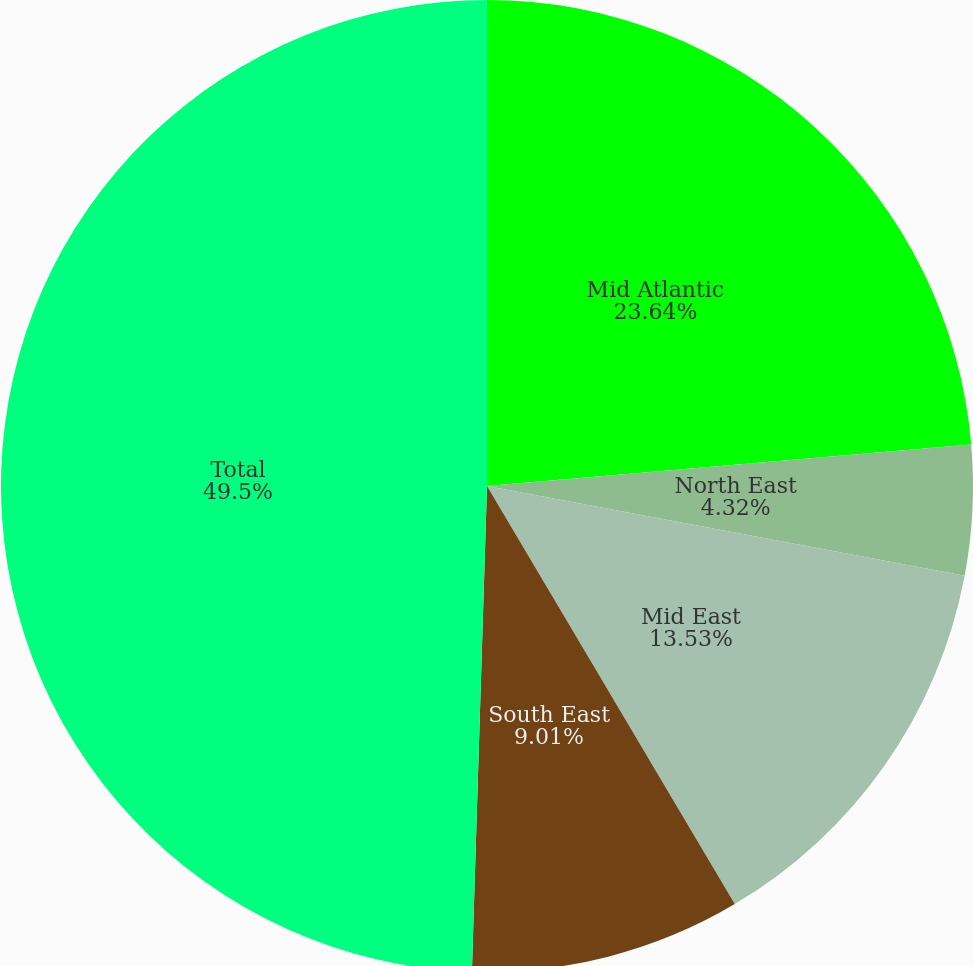Convert chart to OTSL. <chart><loc_0><loc_0><loc_500><loc_500><pie_chart><fcel>Mid Atlantic<fcel>North East<fcel>Mid East<fcel>South East<fcel>Total<nl><fcel>23.64%<fcel>4.32%<fcel>13.53%<fcel>9.01%<fcel>49.51%<nl></chart> 